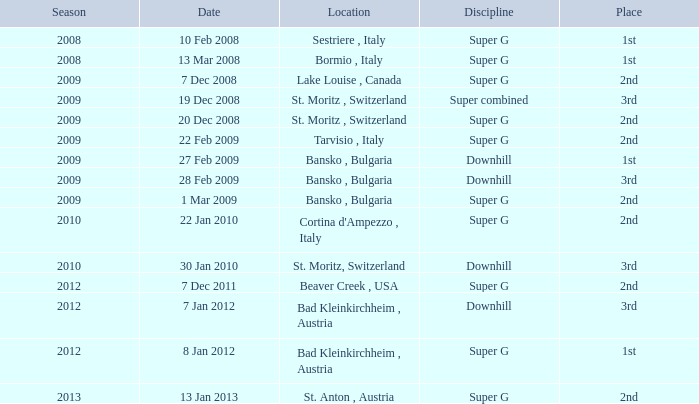What is the date of Super G in the 2010 season? 22 Jan 2010. 